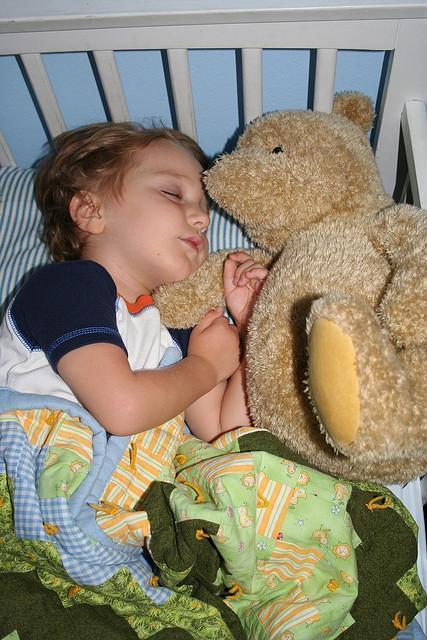Is the caption "The teddy bear is facing the person." a true representation of the image?
Answer yes or no. Yes. Is this affirmation: "The teddy bear is touching the person." correct?
Answer yes or no. Yes. 